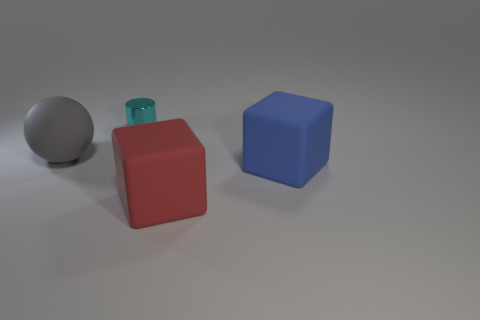How many objects are either rubber cubes or matte objects right of the small metallic thing?
Give a very brief answer. 2. Is there any other thing that is the same shape as the large red thing?
Make the answer very short. Yes. Is the size of the thing that is left of the cyan thing the same as the tiny cyan thing?
Your answer should be very brief. No. What number of metallic things are large cyan spheres or big red things?
Ensure brevity in your answer.  0. There is a block behind the red object; what is its size?
Ensure brevity in your answer.  Large. Do the cyan metallic thing and the large red object have the same shape?
Your answer should be very brief. No. What number of small objects are blue matte things or yellow objects?
Provide a succinct answer. 0. Are there any small cyan metal cylinders in front of the rubber sphere?
Make the answer very short. No. Is the number of blue cubes left of the cyan cylinder the same as the number of yellow metal things?
Your response must be concise. Yes. There is another matte thing that is the same shape as the blue rubber thing; what size is it?
Make the answer very short. Large. 